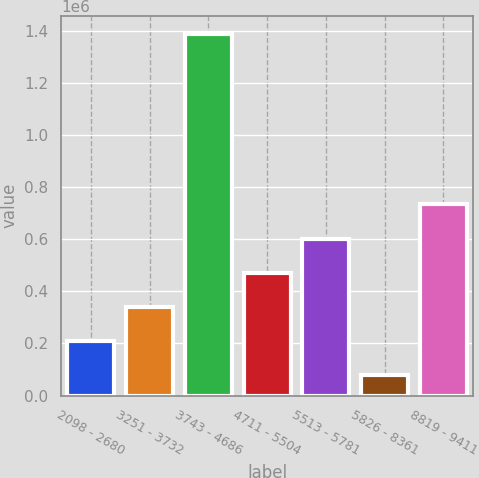Convert chart. <chart><loc_0><loc_0><loc_500><loc_500><bar_chart><fcel>2098 - 2680<fcel>3251 - 3732<fcel>3743 - 4686<fcel>4711 - 5504<fcel>5513 - 5781<fcel>5826 - 8361<fcel>8819 - 9411<nl><fcel>210266<fcel>341157<fcel>1.38829e+06<fcel>472049<fcel>602940<fcel>79375<fcel>733831<nl></chart> 